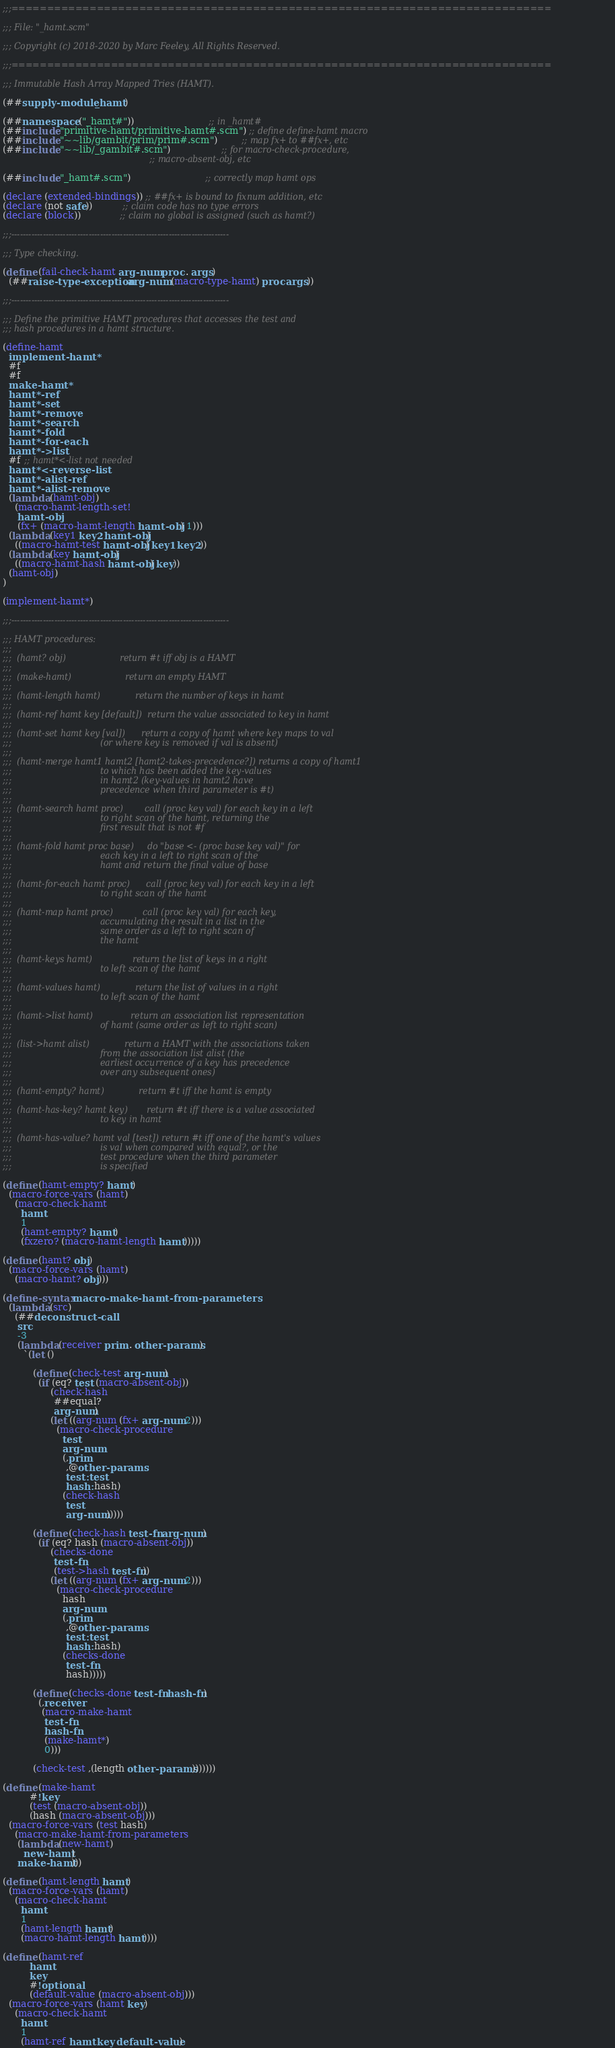Convert code to text. <code><loc_0><loc_0><loc_500><loc_500><_Scheme_>;;;============================================================================

;;; File: "_hamt.scm"

;;; Copyright (c) 2018-2020 by Marc Feeley, All Rights Reserved.

;;;============================================================================

;;; Immutable Hash Array Mapped Tries (HAMT).

(##supply-module _hamt)

(##namespace ("_hamt#"))                         ;; in _hamt#
(##include "primitive-hamt/primitive-hamt#.scm") ;; define define-hamt macro
(##include "~~lib/gambit/prim/prim#.scm")        ;; map fx+ to ##fx+, etc
(##include "~~lib/_gambit#.scm")                 ;; for macro-check-procedure,
                                                 ;; macro-absent-obj, etc

(##include "_hamt#.scm")                         ;; correctly map hamt ops

(declare (extended-bindings)) ;; ##fx+ is bound to fixnum addition, etc
(declare (not safe))          ;; claim code has no type errors
(declare (block))             ;; claim no global is assigned (such as hamt?)

;;;----------------------------------------------------------------------------

;;; Type checking.

(define (fail-check-hamt arg-num proc . args)
  (##raise-type-exception arg-num (macro-type-hamt) proc args))

;;;----------------------------------------------------------------------------

;;; Define the primitive HAMT procedures that accesses the test and
;;; hash procedures in a hamt structure.

(define-hamt
  implement-hamt*
  #f
  #f
  make-hamt*
  hamt*-ref
  hamt*-set
  hamt*-remove
  hamt*-search
  hamt*-fold
  hamt*-for-each
  hamt*->list
  #f ;; hamt*<-list not needed
  hamt*<-reverse-list
  hamt*-alist-ref
  hamt*-alist-remove
  (lambda (hamt-obj)
    (macro-hamt-length-set!
     hamt-obj
     (fx+ (macro-hamt-length hamt-obj) 1)))
  (lambda (key1 key2 hamt-obj)
    ((macro-hamt-test hamt-obj) key1 key2))
  (lambda (key hamt-obj)
    ((macro-hamt-hash hamt-obj) key))
  (hamt-obj)
)

(implement-hamt*)

;;;----------------------------------------------------------------------------

;;; HAMT procedures:
;;;
;;;  (hamt? obj)                    return #t iff obj is a HAMT
;;;
;;;  (make-hamt)                    return an empty HAMT
;;;
;;;  (hamt-length hamt)             return the number of keys in hamt
;;;
;;;  (hamt-ref hamt key [default])  return the value associated to key in hamt
;;;
;;;  (hamt-set hamt key [val])      return a copy of hamt where key maps to val
;;;                                 (or where key is removed if val is absent)
;;;
;;;  (hamt-merge hamt1 hamt2 [hamt2-takes-precedence?]) returns a copy of hamt1
;;;                                 to which has been added the key-values
;;;                                 in hamt2 (key-values in hamt2 have
;;;                                 precedence when third parameter is #t)
;;;
;;;  (hamt-search hamt proc)        call (proc key val) for each key in a left
;;;                                 to right scan of the hamt, returning the
;;;                                 first result that is not #f
;;;
;;;  (hamt-fold hamt proc base)     do "base <- (proc base key val)" for
;;;                                 each key in a left to right scan of the
;;;                                 hamt and return the final value of base
;;;
;;;  (hamt-for-each hamt proc)      call (proc key val) for each key in a left
;;;                                 to right scan of the hamt
;;;
;;;  (hamt-map hamt proc)           call (proc key val) for each key,
;;;                                 accumulating the result in a list in the
;;;                                 same order as a left to right scan of
;;;                                 the hamt
;;;
;;;  (hamt-keys hamt)               return the list of keys in a right
;;;                                 to left scan of the hamt
;;;
;;;  (hamt-values hamt)             return the list of values in a right
;;;                                 to left scan of the hamt
;;;
;;;  (hamt->list hamt)              return an association list representation
;;;                                 of hamt (same order as left to right scan)
;;;
;;;  (list->hamt alist)             return a HAMT with the associations taken
;;;                                 from the association list alist (the
;;;                                 earliest occurrence of a key has precedence
;;;                                 over any subsequent ones)
;;;
;;;  (hamt-empty? hamt)             return #t iff the hamt is empty
;;;
;;;  (hamt-has-key? hamt key)       return #t iff there is a value associated
;;;                                 to key in hamt
;;;
;;;  (hamt-has-value? hamt val [test]) return #t iff one of the hamt's values
;;;                                 is val when compared with equal?, or the
;;;                                 test procedure when the third parameter
;;;                                 is specified

(define (hamt-empty? hamt)
  (macro-force-vars (hamt)
    (macro-check-hamt
      hamt
      1
      (hamt-empty? hamt)
      (fxzero? (macro-hamt-length hamt)))))

(define (hamt? obj)
  (macro-force-vars (hamt)
    (macro-hamt? obj)))

(define-syntax macro-make-hamt-from-parameters
  (lambda (src)
    (##deconstruct-call
     src
     -3
     (lambda (receiver prim . other-params)
       `(let ()

          (define (check-test arg-num)
            (if (eq? test (macro-absent-obj))
                (check-hash
                 ##equal?
                 arg-num)
                (let ((arg-num (fx+ arg-num 2)))
                  (macro-check-procedure
                    test
                    arg-num
                    (,prim
                     ,@other-params
                     test: test
                     hash: hash)
                    (check-hash
                     test
                     arg-num)))))

          (define (check-hash test-fn arg-num)
            (if (eq? hash (macro-absent-obj))
                (checks-done
                 test-fn
                 (test->hash test-fn))
                (let ((arg-num (fx+ arg-num 2)))
                  (macro-check-procedure
                    hash
                    arg-num
                    (,prim
                     ,@other-params
                     test: test
                     hash: hash)
                    (checks-done
                     test-fn
                     hash)))))

          (define (checks-done test-fn hash-fn)
            (,receiver
             (macro-make-hamt
              test-fn
              hash-fn
              (make-hamt*)
              0)))

          (check-test ,(length other-params)))))))

(define (make-hamt
         #!key
         (test (macro-absent-obj))
         (hash (macro-absent-obj)))
  (macro-force-vars (test hash)
    (macro-make-hamt-from-parameters
     (lambda (new-hamt)
       new-hamt)
     make-hamt)))

(define (hamt-length hamt)
  (macro-force-vars (hamt)
    (macro-check-hamt
      hamt
      1
      (hamt-length hamt)
      (macro-hamt-length hamt))))

(define (hamt-ref
         hamt
         key
         #!optional
         (default-value (macro-absent-obj)))
  (macro-force-vars (hamt key)
    (macro-check-hamt
      hamt
      1
      (hamt-ref hamt key default-value)</code> 